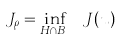Convert formula to latex. <formula><loc_0><loc_0><loc_500><loc_500>J _ { \rho } = \inf _ { H \cap B _ { \rho } } \ J ( u )</formula> 